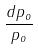Convert formula to latex. <formula><loc_0><loc_0><loc_500><loc_500>\frac { d p _ { o } } { p _ { o } }</formula> 